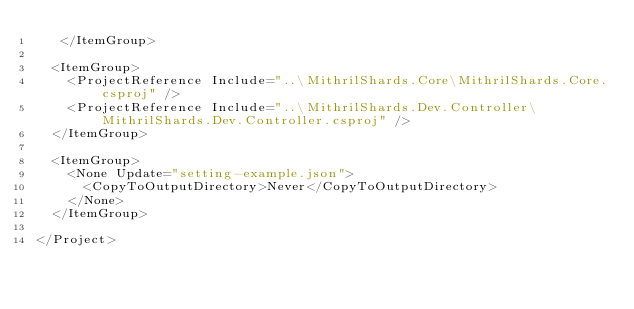<code> <loc_0><loc_0><loc_500><loc_500><_XML_>   </ItemGroup>

  <ItemGroup>
    <ProjectReference Include="..\MithrilShards.Core\MithrilShards.Core.csproj" />
    <ProjectReference Include="..\MithrilShards.Dev.Controller\MithrilShards.Dev.Controller.csproj" />
  </ItemGroup>

  <ItemGroup>
    <None Update="setting-example.json">
      <CopyToOutputDirectory>Never</CopyToOutputDirectory>
    </None>
  </ItemGroup>

</Project>
</code> 